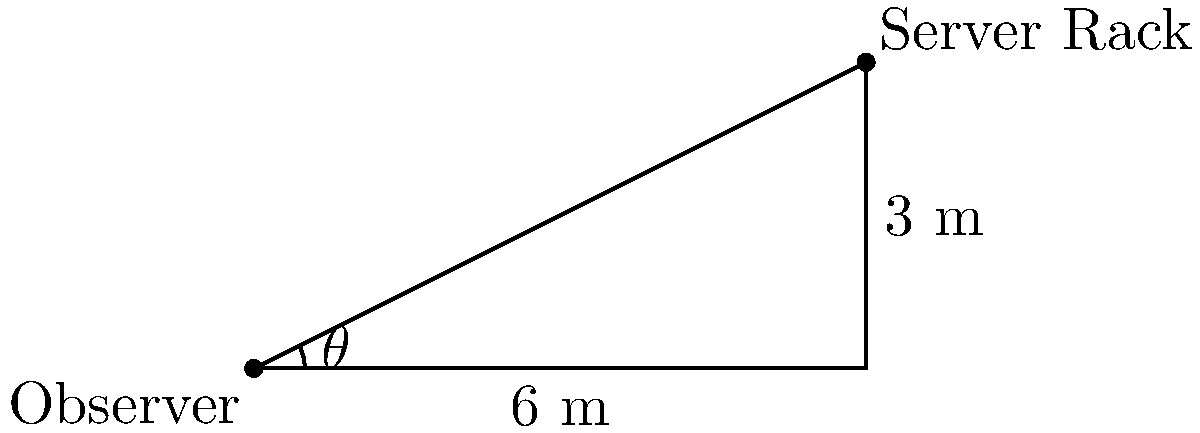An IT infrastructure expert is installing a new server rack in a data center. The top of the rack is 3 meters high and positioned 6 meters away from where the expert is standing. What is the angle of elevation (θ) from the expert's eye level to the top of the server rack? Round your answer to the nearest degree. To solve this problem, we'll use trigonometry, specifically the tangent function. Here's a step-by-step approach:

1) In a right-angled triangle, tangent of an angle is the ratio of the opposite side to the adjacent side.

2) In this case:
   - The opposite side is the height of the server rack: 3 meters
   - The adjacent side is the distance from the observer to the rack: 6 meters

3) We can express this as:

   $$\tan(\theta) = \frac{\text{opposite}}{\text{adjacent}} = \frac{3}{6} = \frac{1}{2} = 0.5$$

4) To find θ, we need to use the inverse tangent (arctangent) function:

   $$\theta = \tan^{-1}(0.5)$$

5) Using a calculator or trigonometric tables:

   $$\theta \approx 26.57°$$

6) Rounding to the nearest degree:

   $$\theta \approx 27°$$

Therefore, the angle of elevation from the expert's eye level to the top of the server rack is approximately 27 degrees.
Answer: 27° 